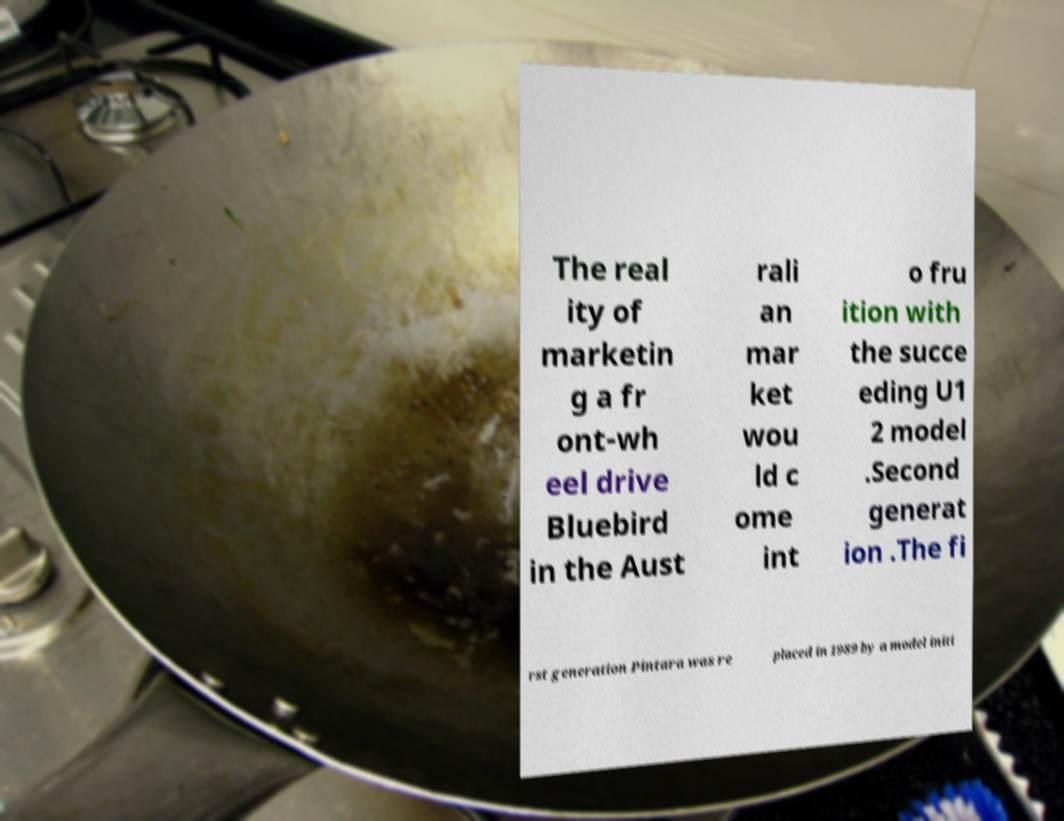Can you read and provide the text displayed in the image?This photo seems to have some interesting text. Can you extract and type it out for me? The real ity of marketin g a fr ont-wh eel drive Bluebird in the Aust rali an mar ket wou ld c ome int o fru ition with the succe eding U1 2 model .Second generat ion .The fi rst generation Pintara was re placed in 1989 by a model initi 